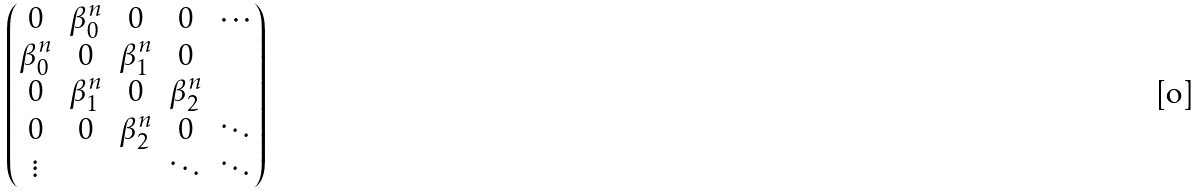<formula> <loc_0><loc_0><loc_500><loc_500>\left ( \begin{matrix} 0 & \beta _ { 0 } ^ { n } & 0 & 0 & \cdots \\ \beta _ { 0 } ^ { n } & 0 & \beta _ { 1 } ^ { n } & 0 \\ 0 & \beta _ { 1 } ^ { n } & 0 & \beta _ { 2 } ^ { n } \\ 0 & 0 & \beta _ { 2 } ^ { n } & 0 & \ddots \\ \vdots & & & \ddots & \ddots \end{matrix} \right )</formula> 